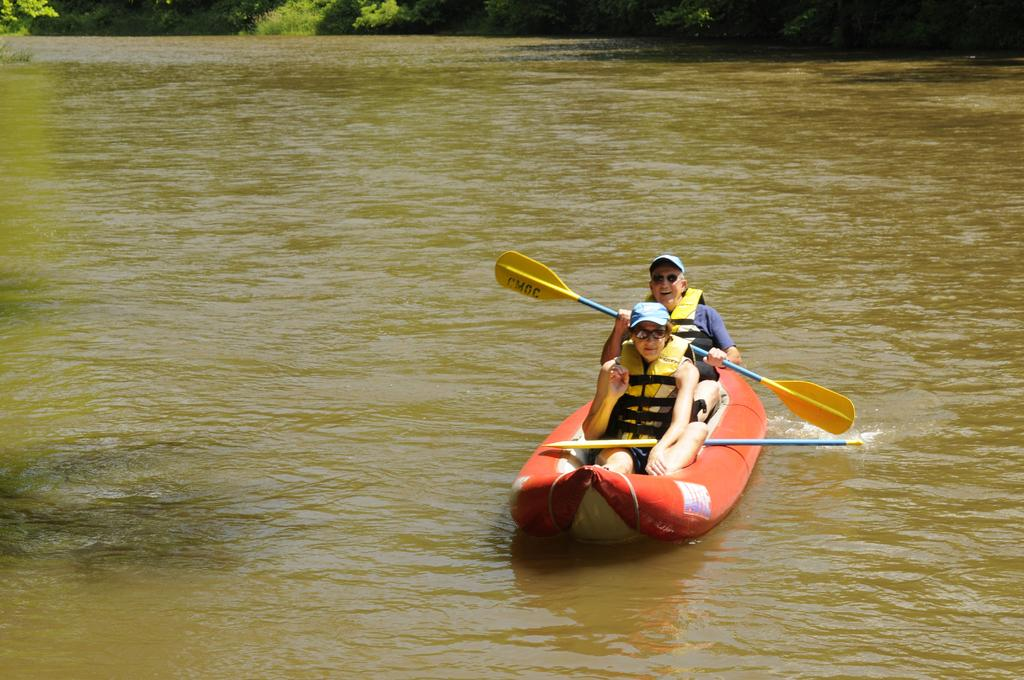How many people are in the image? There are two people in the image. What are the people doing in the image? The people are sailing a boat. Where is the boat located in the image? The boat is on the water. Who is holding a paddle in the image? There is a person holding a paddle. What can be seen at the top of the image? Plants are visible at the top of the image. How many clocks can be seen on the island in the image? There is no island present in the image, and therefore no clocks can be seen on it. 